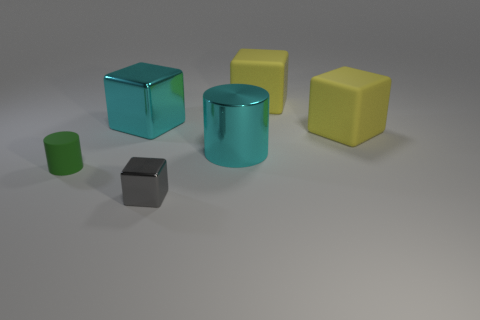Do the shiny cylinder and the green cylinder have the same size?
Keep it short and to the point. No. Is there a big metal cylinder of the same color as the big shiny cube?
Provide a succinct answer. Yes. There is a metal object in front of the tiny green matte cylinder; is its size the same as the cyan object that is to the left of the gray shiny cube?
Provide a short and direct response. No. There is a thing that is to the right of the cyan metal cube and to the left of the cyan shiny cylinder; what is its size?
Offer a terse response. Small. Are there any tiny objects that are to the left of the cylinder that is right of the tiny green rubber object?
Keep it short and to the point. Yes. How many big blocks are there?
Provide a succinct answer. 3. Do the big shiny cylinder and the metal block behind the cyan cylinder have the same color?
Your response must be concise. Yes. Are there more small green cylinders than red metallic balls?
Ensure brevity in your answer.  Yes. Is there anything else that has the same color as the small matte thing?
Make the answer very short. No. How many other things are the same size as the gray thing?
Give a very brief answer. 1. 